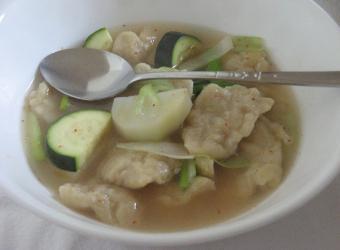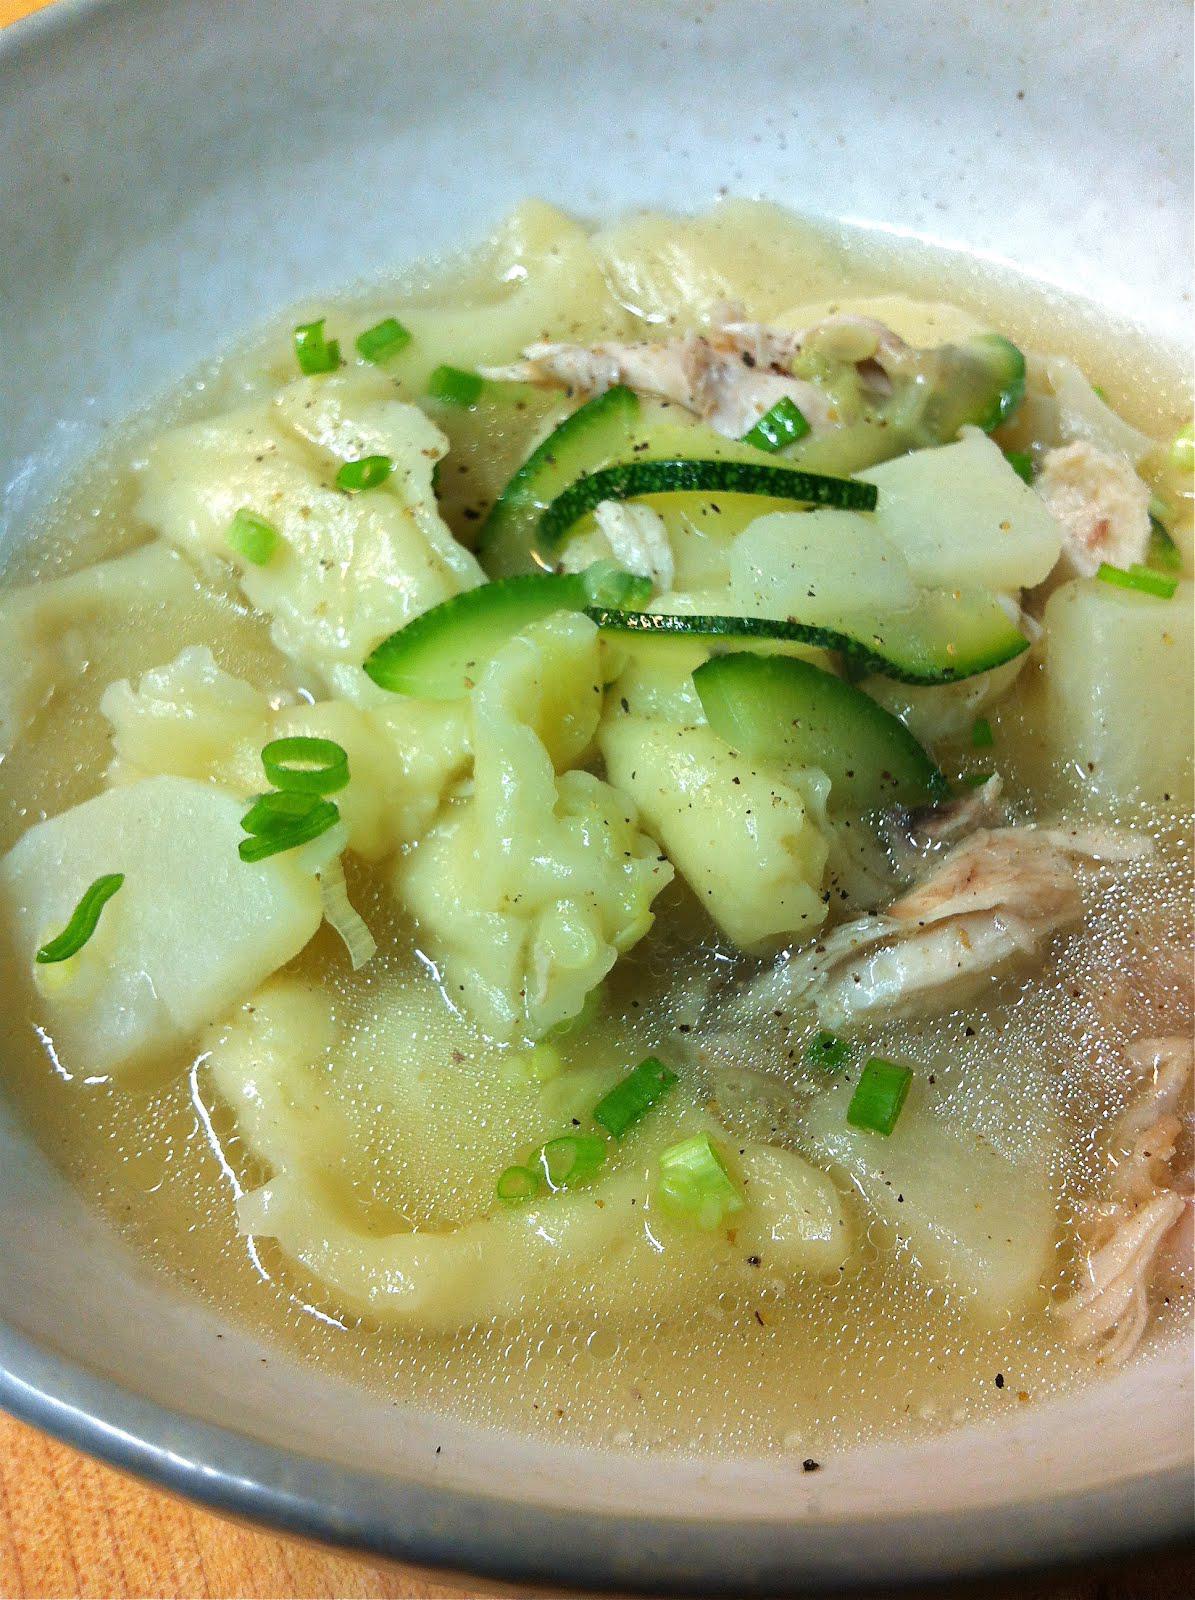The first image is the image on the left, the second image is the image on the right. Considering the images on both sides, is "A metal spoon is over a round container of broth and other ingredients in one image." valid? Answer yes or no. Yes. The first image is the image on the left, the second image is the image on the right. Examine the images to the left and right. Is the description "There is a single white bowl in the left image." accurate? Answer yes or no. Yes. 